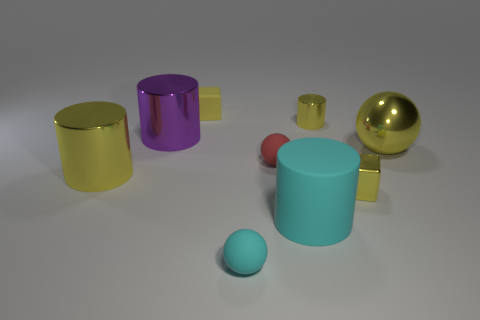Do the tiny yellow cube that is behind the purple shiny cylinder and the large yellow object that is on the right side of the tiny cyan object have the same material?
Keep it short and to the point. No. How many shiny things are either big purple cylinders or big spheres?
Give a very brief answer. 2. The big cylinder right of the small rubber sphere that is in front of the rubber thing that is to the right of the red ball is made of what material?
Offer a terse response. Rubber. Does the small yellow shiny object that is in front of the small cylinder have the same shape as the tiny matte object that is behind the tiny red rubber ball?
Ensure brevity in your answer.  Yes. There is a small block to the right of the matte ball in front of the matte cylinder; what color is it?
Offer a very short reply. Yellow. How many cubes are big green rubber objects or metal things?
Provide a short and direct response. 1. How many purple shiny cylinders are in front of the big yellow object that is on the left side of the tiny ball that is to the right of the cyan matte ball?
Provide a short and direct response. 0. What size is the sphere that is the same color as the small rubber cube?
Your answer should be very brief. Large. Is there a blue cylinder that has the same material as the large cyan cylinder?
Your answer should be compact. No. Are the small red sphere and the big purple cylinder made of the same material?
Your answer should be compact. No. 